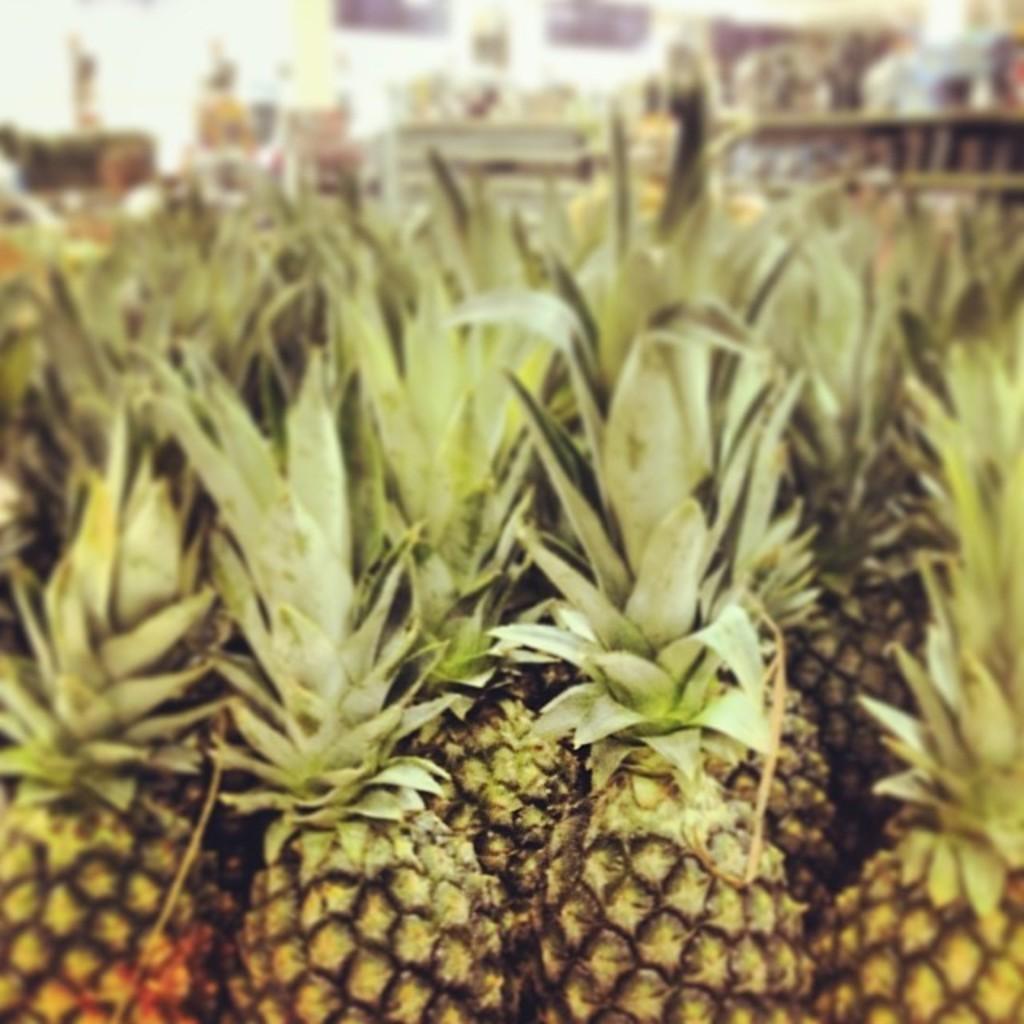Describe this image in one or two sentences. In this image I can see few pineapples which are yellow, black and green in color. I can see the blurry background. 